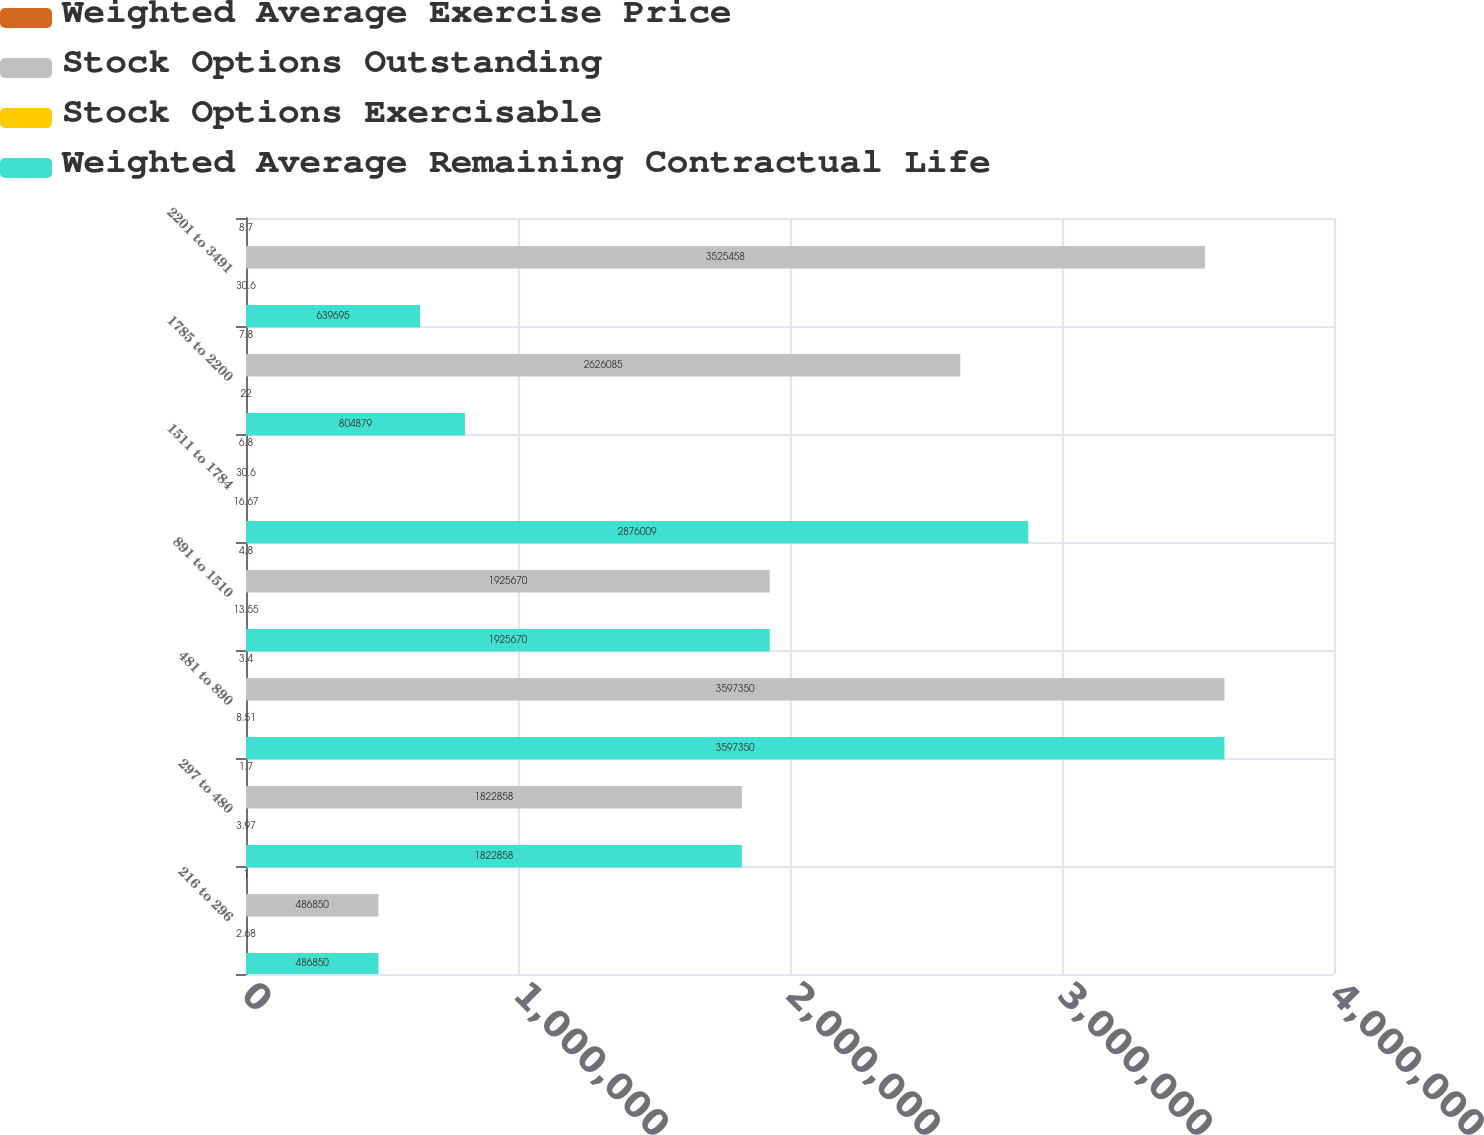Convert chart. <chart><loc_0><loc_0><loc_500><loc_500><stacked_bar_chart><ecel><fcel>216 to 296<fcel>297 to 480<fcel>481 to 890<fcel>891 to 1510<fcel>1511 to 1784<fcel>1785 to 2200<fcel>2201 to 3491<nl><fcel>Weighted Average Exercise Price<fcel>1<fcel>1.7<fcel>3.4<fcel>4.8<fcel>6.8<fcel>7.8<fcel>8.7<nl><fcel>Stock Options Outstanding<fcel>486850<fcel>1.82286e+06<fcel>3.59735e+06<fcel>1.92567e+06<fcel>30.6<fcel>2.62608e+06<fcel>3.52546e+06<nl><fcel>Stock Options Exercisable<fcel>2.68<fcel>3.97<fcel>8.51<fcel>13.55<fcel>16.67<fcel>22<fcel>30.6<nl><fcel>Weighted Average Remaining Contractual Life<fcel>486850<fcel>1.82286e+06<fcel>3.59735e+06<fcel>1.92567e+06<fcel>2.87601e+06<fcel>804879<fcel>639695<nl></chart> 